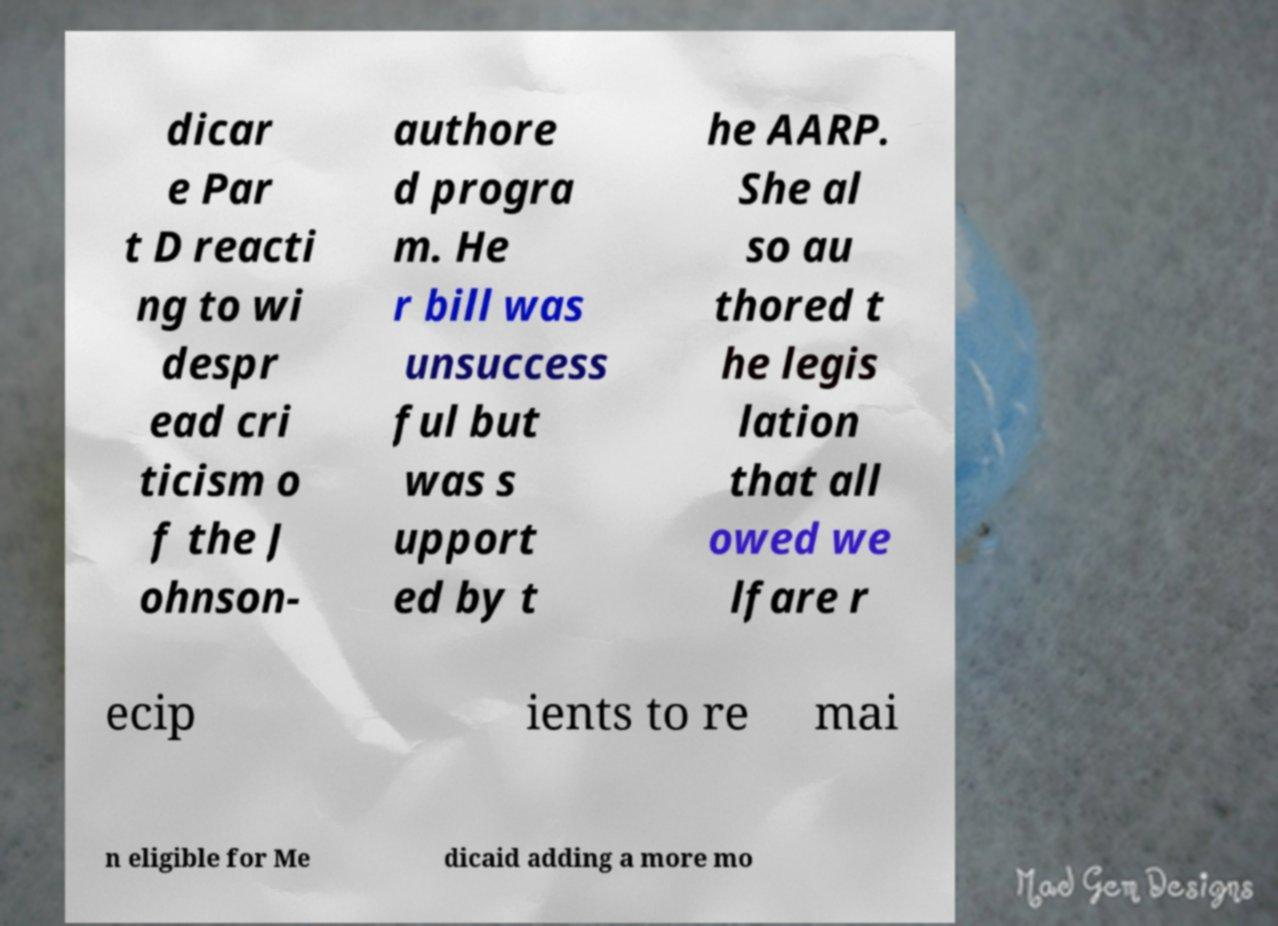For documentation purposes, I need the text within this image transcribed. Could you provide that? dicar e Par t D reacti ng to wi despr ead cri ticism o f the J ohnson- authore d progra m. He r bill was unsuccess ful but was s upport ed by t he AARP. She al so au thored t he legis lation that all owed we lfare r ecip ients to re mai n eligible for Me dicaid adding a more mo 